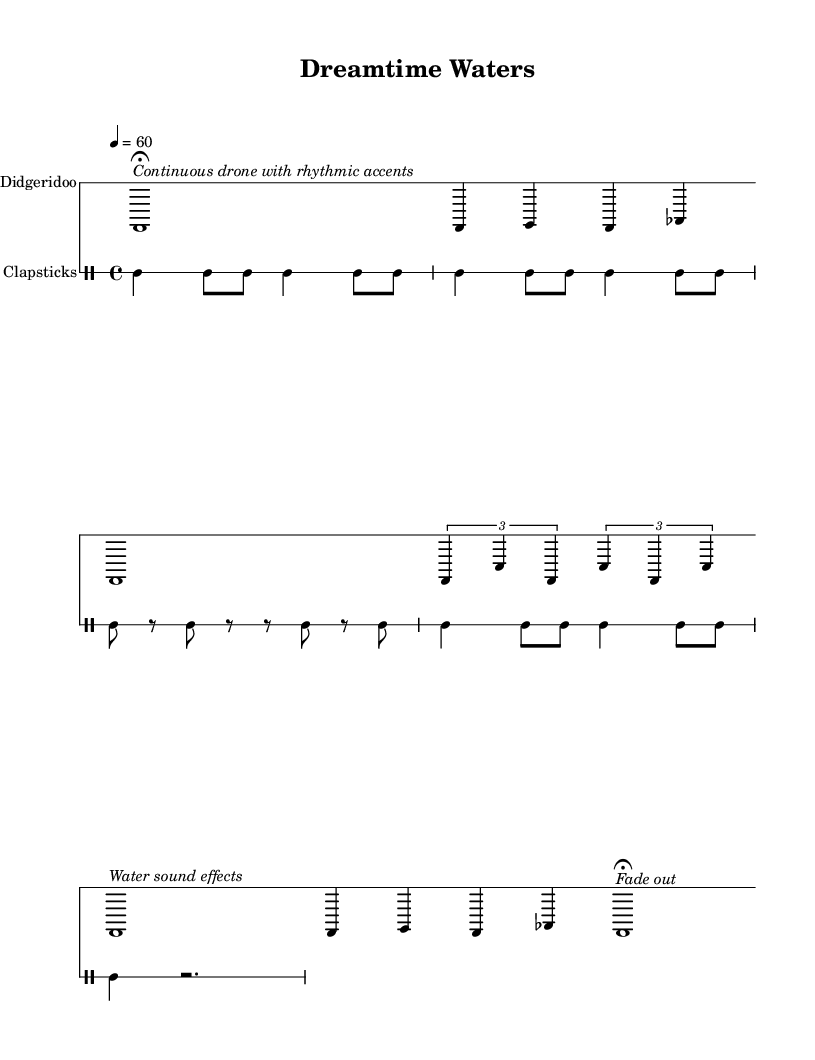what is the time signature of this music? The time signature is indicated at the beginning of the piece as 4/4, which is a common time signature indicating four beats per measure.
Answer: 4/4 what is the tempo marking for this piece? The tempo marking is shown as 4 = 60, which indicates that there are 60 beats per minute.
Answer: 60 how many measures are in the main theme section? The main theme consists of two sections, each containing 4 measures, thus totaling 8 measures in the main theme.
Answer: 8 what is the notation used for the "Water sound effects"? The notation used for the "Water sound effects" is a sustained note ‘c,’ written in a long duration (whole note) with a text indication below it.
Answer: c how many types of instruments are used in this piece? The piece features two types of instruments: the didgeridoo and clapsticks, each represented in separate staves.
Answer: 2 what rhythmic pattern does the clapstick section follow in the main theme? The clapsticks in the main theme follow a repeating rhythmic pattern of quarter and eighth notes, creating a syncopated feel.
Answer: cl4 cl8 cl what cultural significance does the didgeridoo hold in Australian Aboriginal music, particularly related to water? The didgeridoo has a deep spiritual connection in Indigenous culture, often serving as a conduit for expressing the importance of water and land in rituals and storytelling.
Answer: Spiritual connection to water and land 